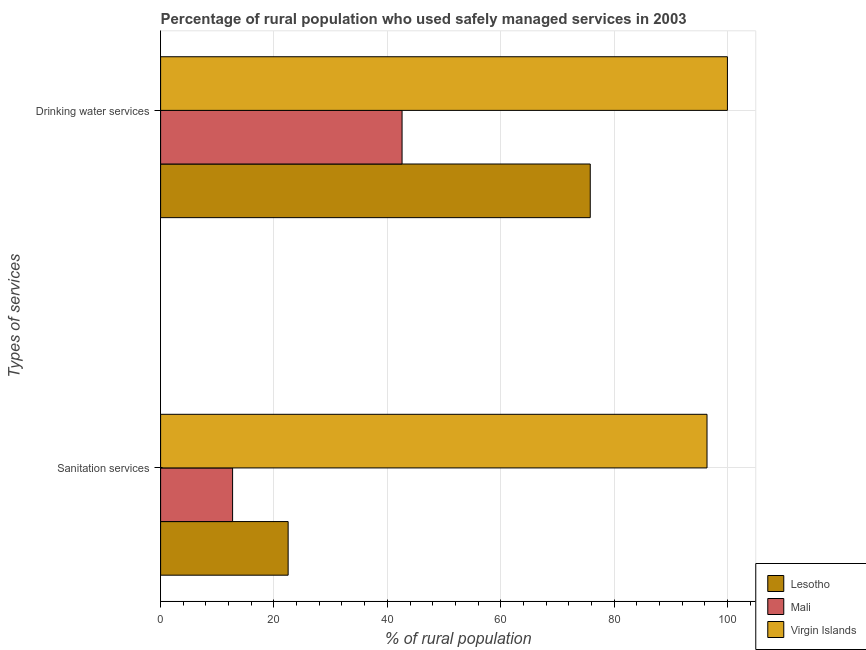How many bars are there on the 2nd tick from the bottom?
Ensure brevity in your answer.  3. What is the label of the 1st group of bars from the top?
Your answer should be very brief. Drinking water services. What is the percentage of rural population who used sanitation services in Virgin Islands?
Provide a short and direct response. 96.4. Across all countries, what is the minimum percentage of rural population who used drinking water services?
Provide a short and direct response. 42.6. In which country was the percentage of rural population who used sanitation services maximum?
Ensure brevity in your answer.  Virgin Islands. In which country was the percentage of rural population who used drinking water services minimum?
Offer a very short reply. Mali. What is the total percentage of rural population who used drinking water services in the graph?
Offer a terse response. 218.4. What is the difference between the percentage of rural population who used drinking water services in Mali and that in Lesotho?
Your answer should be compact. -33.2. What is the difference between the percentage of rural population who used drinking water services in Lesotho and the percentage of rural population who used sanitation services in Mali?
Make the answer very short. 63.1. What is the average percentage of rural population who used sanitation services per country?
Provide a succinct answer. 43.87. What is the difference between the percentage of rural population who used drinking water services and percentage of rural population who used sanitation services in Virgin Islands?
Your response must be concise. 3.6. In how many countries, is the percentage of rural population who used drinking water services greater than 40 %?
Offer a very short reply. 3. What is the ratio of the percentage of rural population who used drinking water services in Virgin Islands to that in Mali?
Offer a terse response. 2.35. In how many countries, is the percentage of rural population who used sanitation services greater than the average percentage of rural population who used sanitation services taken over all countries?
Provide a short and direct response. 1. What does the 1st bar from the top in Sanitation services represents?
Provide a short and direct response. Virgin Islands. What does the 2nd bar from the bottom in Drinking water services represents?
Make the answer very short. Mali. How many bars are there?
Your response must be concise. 6. What is the difference between two consecutive major ticks on the X-axis?
Provide a succinct answer. 20. Are the values on the major ticks of X-axis written in scientific E-notation?
Give a very brief answer. No. Does the graph contain grids?
Provide a short and direct response. Yes. How are the legend labels stacked?
Your response must be concise. Vertical. What is the title of the graph?
Offer a very short reply. Percentage of rural population who used safely managed services in 2003. What is the label or title of the X-axis?
Your response must be concise. % of rural population. What is the label or title of the Y-axis?
Give a very brief answer. Types of services. What is the % of rural population of Mali in Sanitation services?
Offer a terse response. 12.7. What is the % of rural population in Virgin Islands in Sanitation services?
Your answer should be very brief. 96.4. What is the % of rural population in Lesotho in Drinking water services?
Your answer should be very brief. 75.8. What is the % of rural population of Mali in Drinking water services?
Keep it short and to the point. 42.6. What is the % of rural population in Virgin Islands in Drinking water services?
Your answer should be compact. 100. Across all Types of services, what is the maximum % of rural population of Lesotho?
Ensure brevity in your answer.  75.8. Across all Types of services, what is the maximum % of rural population of Mali?
Offer a terse response. 42.6. Across all Types of services, what is the maximum % of rural population of Virgin Islands?
Give a very brief answer. 100. Across all Types of services, what is the minimum % of rural population of Mali?
Ensure brevity in your answer.  12.7. Across all Types of services, what is the minimum % of rural population of Virgin Islands?
Provide a succinct answer. 96.4. What is the total % of rural population in Lesotho in the graph?
Provide a succinct answer. 98.3. What is the total % of rural population of Mali in the graph?
Give a very brief answer. 55.3. What is the total % of rural population of Virgin Islands in the graph?
Make the answer very short. 196.4. What is the difference between the % of rural population of Lesotho in Sanitation services and that in Drinking water services?
Your answer should be compact. -53.3. What is the difference between the % of rural population of Mali in Sanitation services and that in Drinking water services?
Provide a short and direct response. -29.9. What is the difference between the % of rural population in Virgin Islands in Sanitation services and that in Drinking water services?
Provide a succinct answer. -3.6. What is the difference between the % of rural population of Lesotho in Sanitation services and the % of rural population of Mali in Drinking water services?
Provide a succinct answer. -20.1. What is the difference between the % of rural population of Lesotho in Sanitation services and the % of rural population of Virgin Islands in Drinking water services?
Provide a succinct answer. -77.5. What is the difference between the % of rural population in Mali in Sanitation services and the % of rural population in Virgin Islands in Drinking water services?
Keep it short and to the point. -87.3. What is the average % of rural population of Lesotho per Types of services?
Your answer should be very brief. 49.15. What is the average % of rural population in Mali per Types of services?
Give a very brief answer. 27.65. What is the average % of rural population in Virgin Islands per Types of services?
Your response must be concise. 98.2. What is the difference between the % of rural population of Lesotho and % of rural population of Mali in Sanitation services?
Make the answer very short. 9.8. What is the difference between the % of rural population in Lesotho and % of rural population in Virgin Islands in Sanitation services?
Your answer should be compact. -73.9. What is the difference between the % of rural population of Mali and % of rural population of Virgin Islands in Sanitation services?
Give a very brief answer. -83.7. What is the difference between the % of rural population of Lesotho and % of rural population of Mali in Drinking water services?
Keep it short and to the point. 33.2. What is the difference between the % of rural population of Lesotho and % of rural population of Virgin Islands in Drinking water services?
Your response must be concise. -24.2. What is the difference between the % of rural population in Mali and % of rural population in Virgin Islands in Drinking water services?
Offer a terse response. -57.4. What is the ratio of the % of rural population of Lesotho in Sanitation services to that in Drinking water services?
Give a very brief answer. 0.3. What is the ratio of the % of rural population in Mali in Sanitation services to that in Drinking water services?
Your answer should be very brief. 0.3. What is the ratio of the % of rural population of Virgin Islands in Sanitation services to that in Drinking water services?
Give a very brief answer. 0.96. What is the difference between the highest and the second highest % of rural population of Lesotho?
Your answer should be compact. 53.3. What is the difference between the highest and the second highest % of rural population in Mali?
Your response must be concise. 29.9. What is the difference between the highest and the lowest % of rural population of Lesotho?
Your answer should be very brief. 53.3. What is the difference between the highest and the lowest % of rural population of Mali?
Your response must be concise. 29.9. 